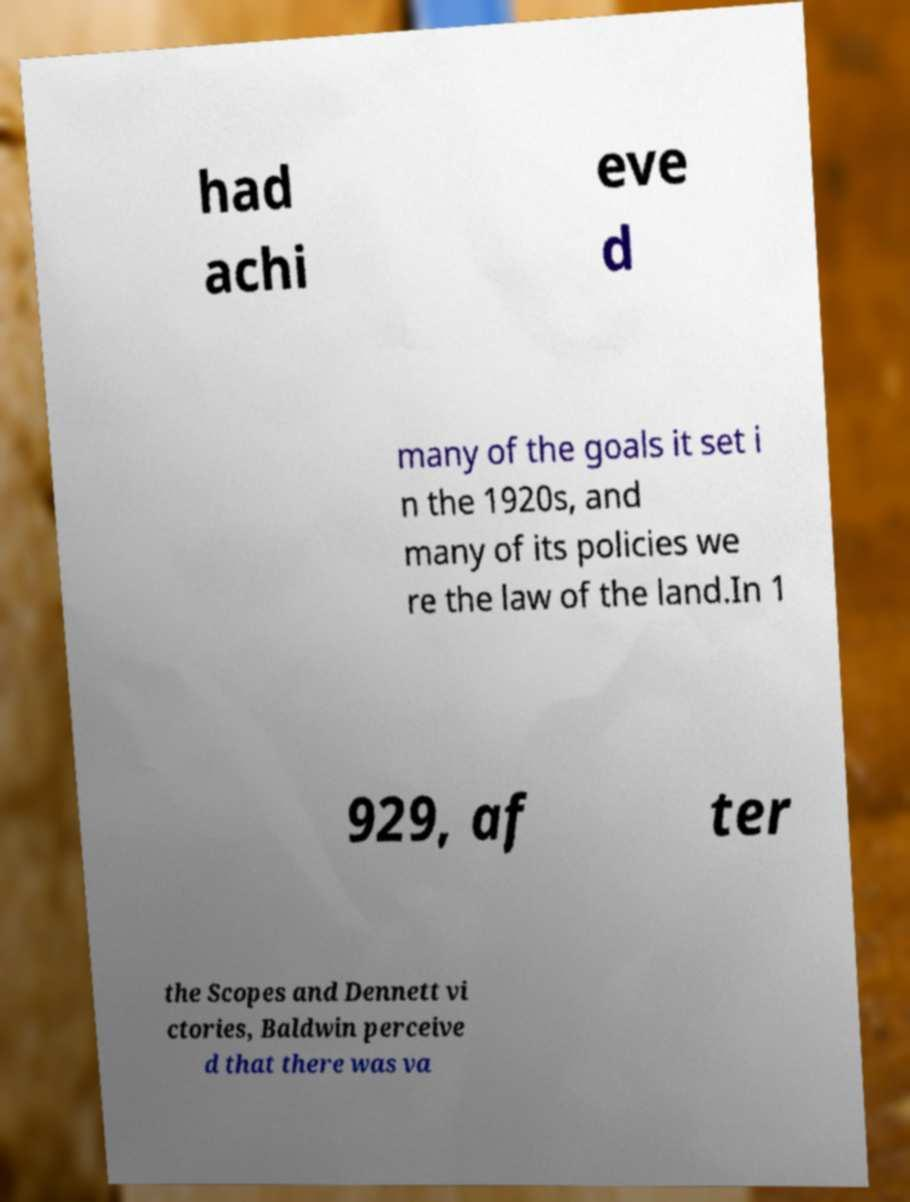Please identify and transcribe the text found in this image. had achi eve d many of the goals it set i n the 1920s, and many of its policies we re the law of the land.In 1 929, af ter the Scopes and Dennett vi ctories, Baldwin perceive d that there was va 